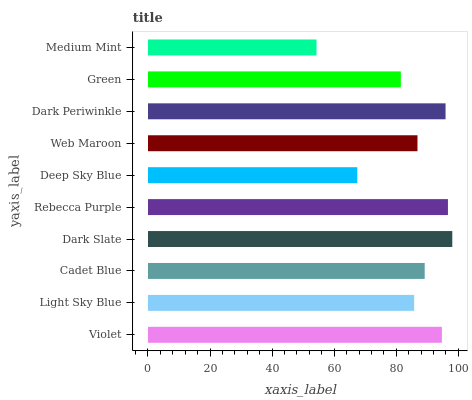Is Medium Mint the minimum?
Answer yes or no. Yes. Is Dark Slate the maximum?
Answer yes or no. Yes. Is Light Sky Blue the minimum?
Answer yes or no. No. Is Light Sky Blue the maximum?
Answer yes or no. No. Is Violet greater than Light Sky Blue?
Answer yes or no. Yes. Is Light Sky Blue less than Violet?
Answer yes or no. Yes. Is Light Sky Blue greater than Violet?
Answer yes or no. No. Is Violet less than Light Sky Blue?
Answer yes or no. No. Is Cadet Blue the high median?
Answer yes or no. Yes. Is Web Maroon the low median?
Answer yes or no. Yes. Is Rebecca Purple the high median?
Answer yes or no. No. Is Dark Periwinkle the low median?
Answer yes or no. No. 